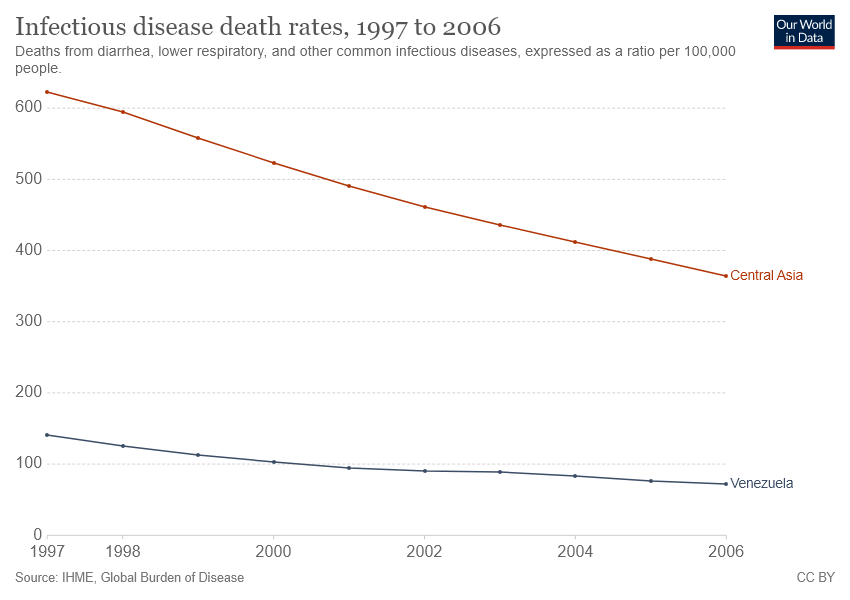List a handful of essential elements in this visual. Central Asia has a higher rate of infectious disease deaths compared to other regions over the course of a year. For at least two years, the death rate from infectious diseases has been below 400 per 100,000 people in Central Asia. 